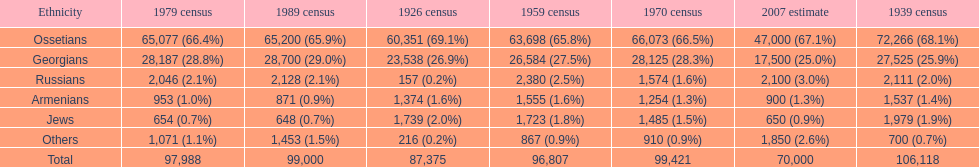How many ethnicities were below 1,000 people in 2007? 2. 